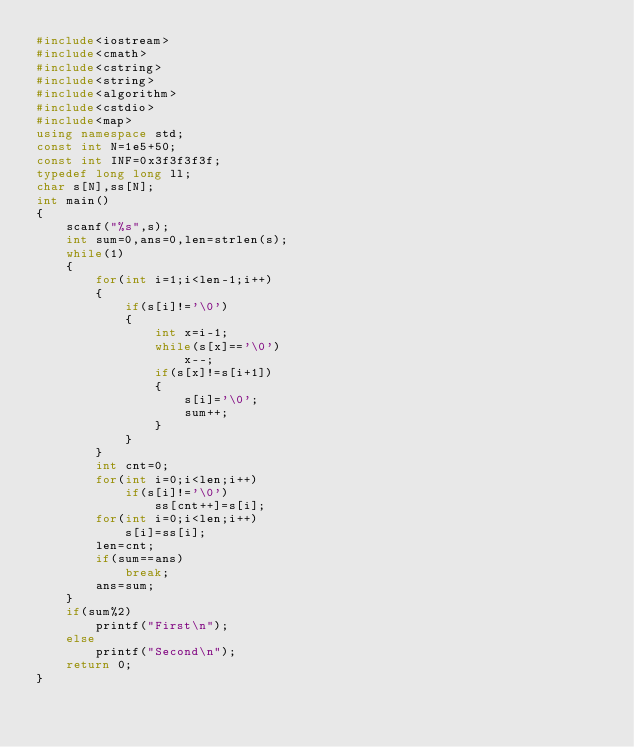<code> <loc_0><loc_0><loc_500><loc_500><_C++_>#include<iostream>
#include<cmath>
#include<cstring>
#include<string>
#include<algorithm>
#include<cstdio>
#include<map>
using namespace std;
const int N=1e5+50;
const int INF=0x3f3f3f3f;
typedef long long ll;
char s[N],ss[N];
int main()
{
    scanf("%s",s);
    int sum=0,ans=0,len=strlen(s);
    while(1)
    {
        for(int i=1;i<len-1;i++)
        {
            if(s[i]!='\0')
            {
                int x=i-1;
                while(s[x]=='\0')
                    x--;
                if(s[x]!=s[i+1])
                {
                    s[i]='\0';
                    sum++;
                }
            }
        }
        int cnt=0;
        for(int i=0;i<len;i++)
            if(s[i]!='\0')
                ss[cnt++]=s[i];
        for(int i=0;i<len;i++)
            s[i]=ss[i];
        len=cnt;
        if(sum==ans)
            break;
        ans=sum;
    }
    if(sum%2)
        printf("First\n");
    else
        printf("Second\n");
    return 0;
}
</code> 